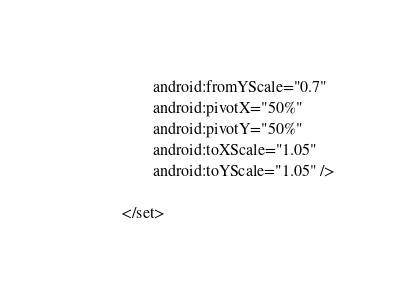<code> <loc_0><loc_0><loc_500><loc_500><_XML_>        android:fromYScale="0.7"
        android:pivotX="50%"
        android:pivotY="50%"
        android:toXScale="1.05"
        android:toYScale="1.05" />

</set></code> 